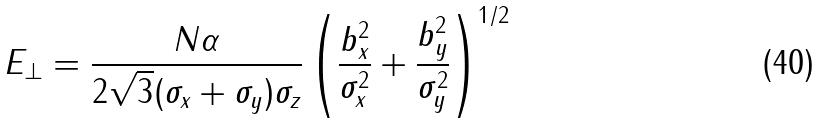Convert formula to latex. <formula><loc_0><loc_0><loc_500><loc_500>E _ { \perp } = { \frac { N \alpha } { 2 \sqrt { 3 } ( \sigma _ { x } + \sigma _ { y } ) \sigma _ { z } } } \left ( { { \frac { b _ { x } ^ { 2 } } { \sigma _ { x } ^ { 2 } } } + { \frac { b _ { y } ^ { 2 } } { \sigma _ { y } ^ { 2 } } } } \right ) ^ { 1 / 2 }</formula> 